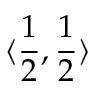Convert formula to latex. <formula><loc_0><loc_0><loc_500><loc_500>\langle { \frac { 1 } { 2 } , \frac { 1 } { 2 } } \rangle</formula> 